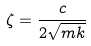<formula> <loc_0><loc_0><loc_500><loc_500>\zeta = \frac { c } { 2 \sqrt { m k } }</formula> 